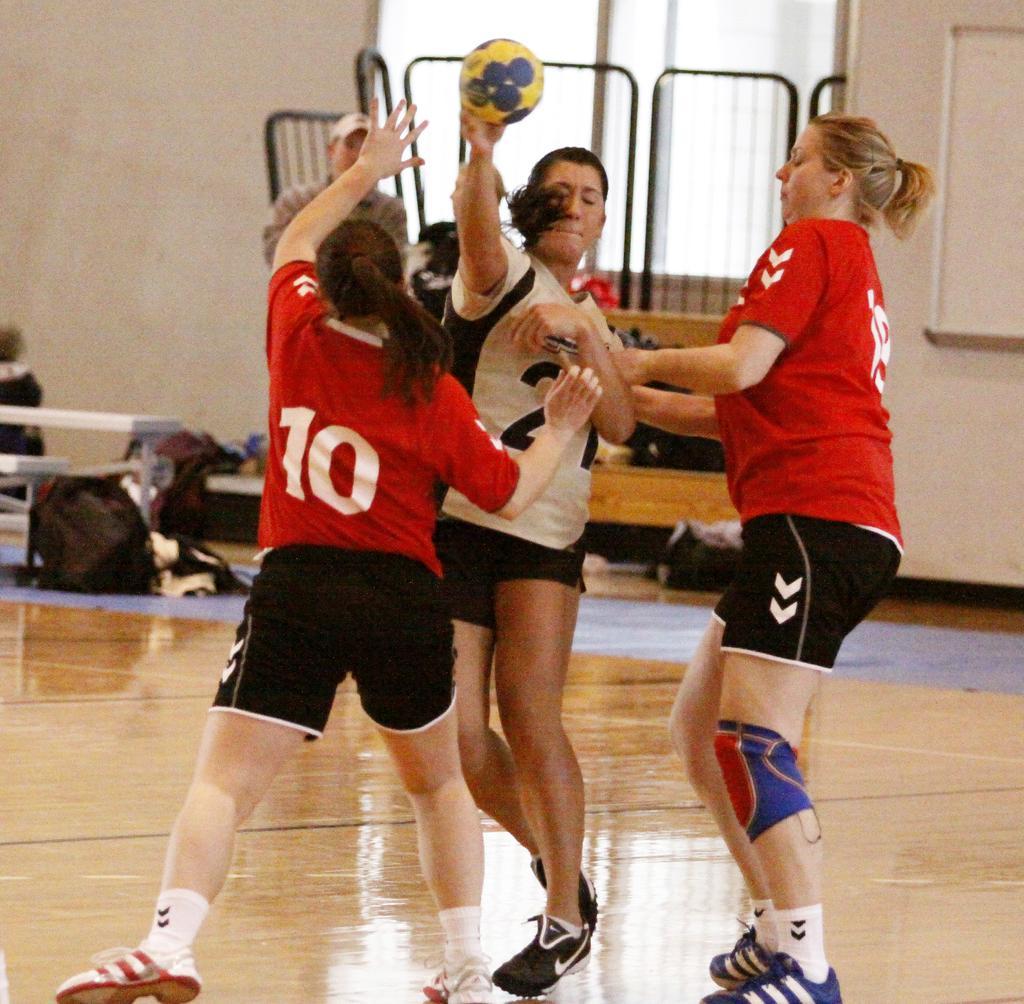Can you describe this image briefly? In this image we can see persons standing on the floor and one of them is holding a ball in the hands. In the background we can see grills, bags on benches and on the floor. 